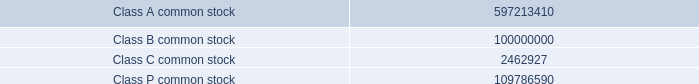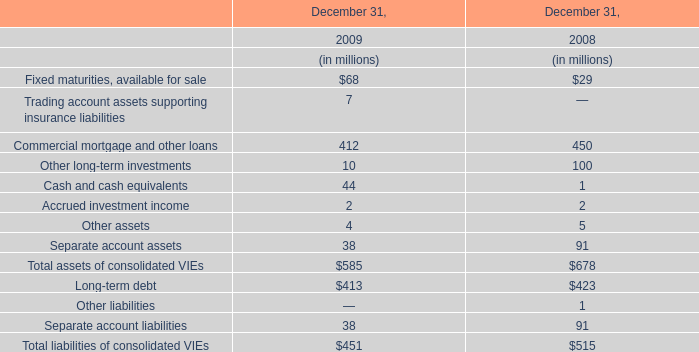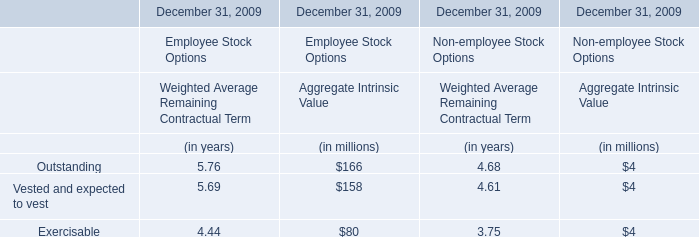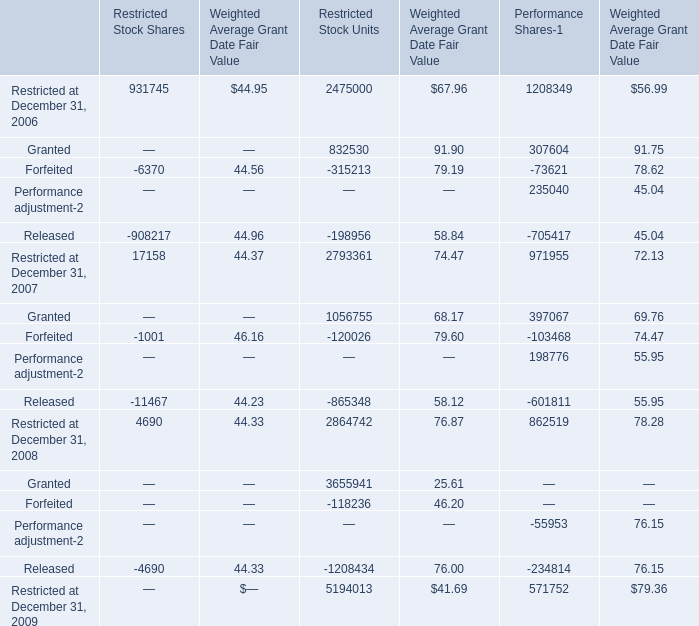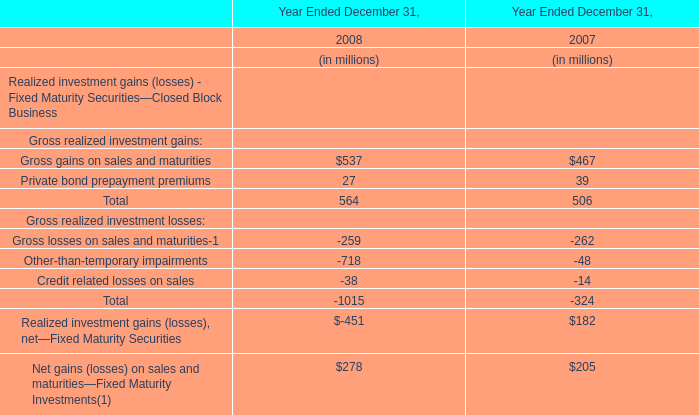What is the percentage of all Aggregate Intrinsic Value that are positive to the total amount, in 2009 for Employee Stock Options? 
Computations: (((166 + 158) + 80) / ((166 + 158) + 80))
Answer: 1.0. 